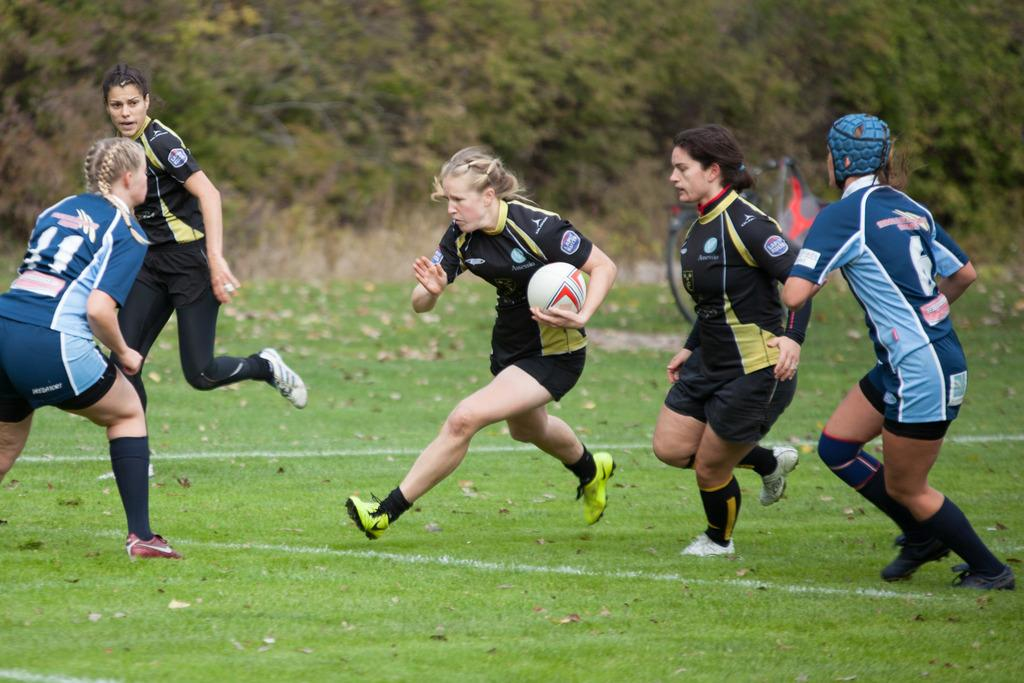How many people are in the image? There are five persons in the image. What are the persons doing in the image? The persons are running. Can you describe any specific objects held by one of the persons? One person is holding a ball. Is there any protective gear worn by any of the persons? Yes, one person is wearing a helmet. What type of terrain is visible in the image? There is grass in the image. What can be seen in the background of the image? There are trees in the background of the image. What type of oil can be seen dripping from the trees in the image? There is no oil visible in the image, and the trees are not depicted as dripping anything. 